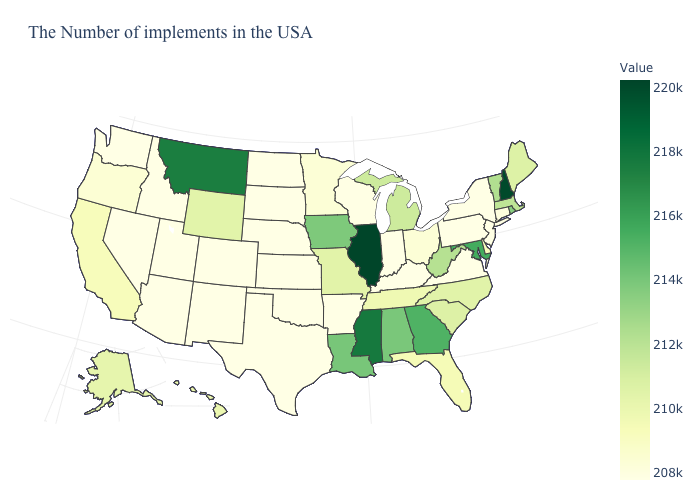Among the states that border Arkansas , does Oklahoma have the highest value?
Quick response, please. No. Among the states that border Kansas , does Colorado have the highest value?
Write a very short answer. No. Which states have the lowest value in the USA?
Write a very short answer. New York, New Jersey, Pennsylvania, Virginia, Kentucky, Indiana, Arkansas, Kansas, Nebraska, Oklahoma, Texas, South Dakota, North Dakota, Colorado, New Mexico, Utah, Arizona, Idaho, Nevada, Washington. 